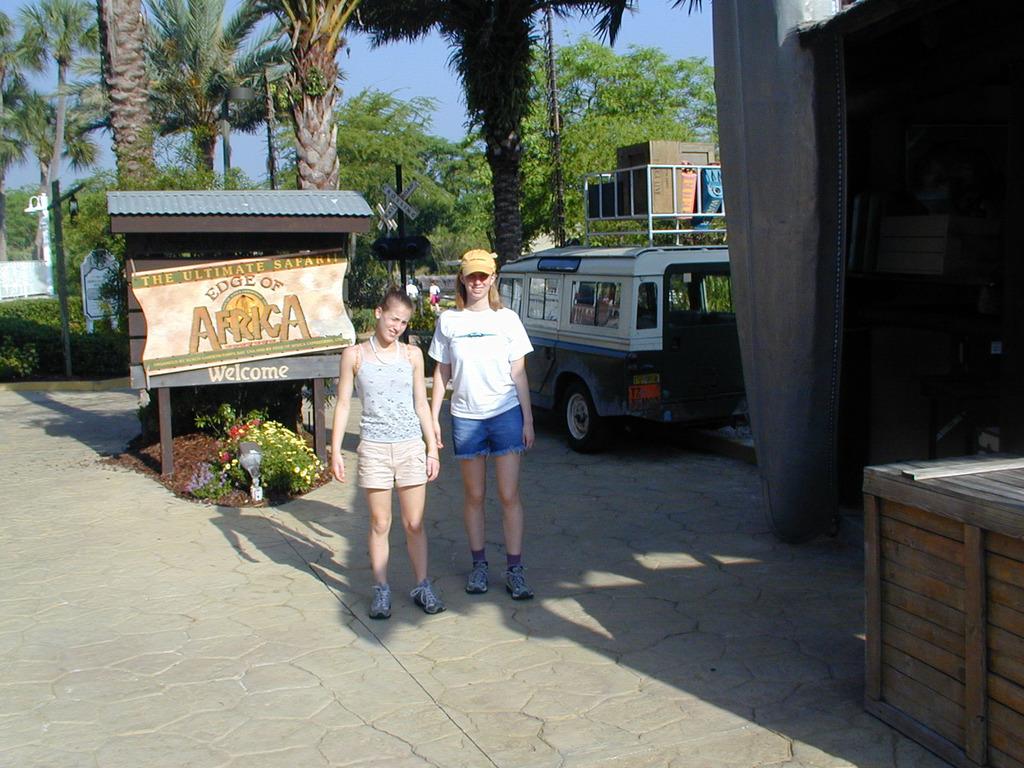Is that a sign post?
Your response must be concise. Yes. What continent does the sign say you are entering?
Provide a short and direct response. Africa. 